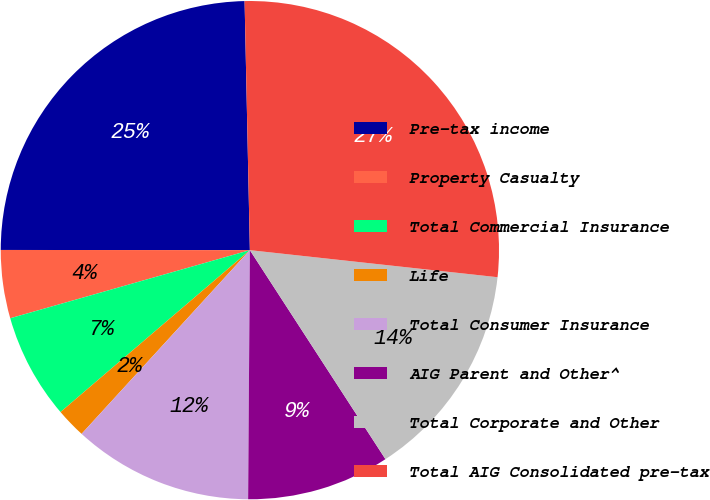<chart> <loc_0><loc_0><loc_500><loc_500><pie_chart><fcel>Pre-tax income<fcel>Property Casualty<fcel>Total Commercial Insurance<fcel>Life<fcel>Total Consumer Insurance<fcel>AIG Parent and Other^<fcel>Total Corporate and Other<fcel>Total AIG Consolidated pre-tax<nl><fcel>24.65%<fcel>4.42%<fcel>6.85%<fcel>1.94%<fcel>11.69%<fcel>9.27%<fcel>14.11%<fcel>27.07%<nl></chart> 